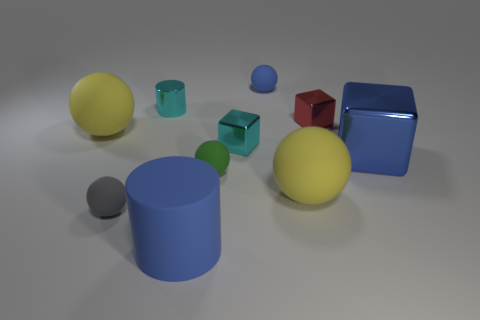There is a big thing that is both to the left of the small blue rubber sphere and behind the small gray sphere; what material is it made of?
Make the answer very short. Rubber. There is a blue thing behind the red cube; are there any large things to the left of it?
Give a very brief answer. Yes. How many other tiny cylinders have the same color as the tiny shiny cylinder?
Your answer should be compact. 0. There is a tiny block that is the same color as the small cylinder; what is it made of?
Provide a succinct answer. Metal. Is the big blue cube made of the same material as the gray thing?
Offer a very short reply. No. Are there any cyan shiny blocks on the left side of the red metallic block?
Give a very brief answer. Yes. The blue thing behind the cyan metallic block that is on the right side of the cyan metal cylinder is made of what material?
Offer a very short reply. Rubber. There is a gray object that is the same shape as the green thing; what is its size?
Provide a short and direct response. Small. Does the large metal thing have the same color as the large cylinder?
Your answer should be very brief. Yes. What color is the rubber ball that is in front of the small green ball and on the right side of the small cyan cube?
Keep it short and to the point. Yellow. 